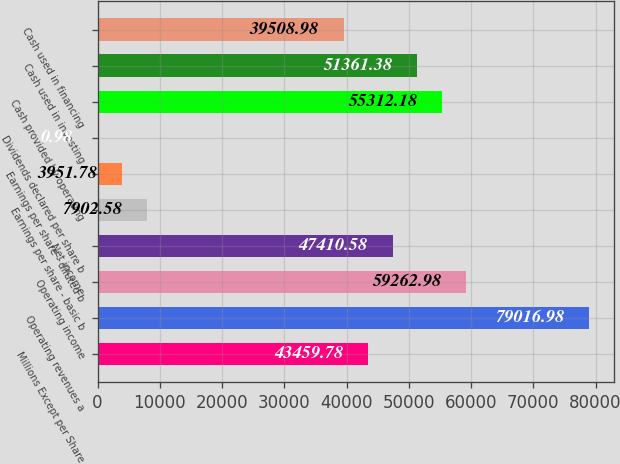Convert chart. <chart><loc_0><loc_0><loc_500><loc_500><bar_chart><fcel>Millions Except per Share<fcel>Operating revenues a<fcel>Operating income<fcel>Net income<fcel>Earnings per share - basic b<fcel>Earnings per share - diluted b<fcel>Dividends declared per share b<fcel>Cash provided by operating<fcel>Cash used in investing<fcel>Cash used in financing<nl><fcel>43459.8<fcel>79017<fcel>59263<fcel>47410.6<fcel>7902.58<fcel>3951.78<fcel>0.98<fcel>55312.2<fcel>51361.4<fcel>39509<nl></chart> 